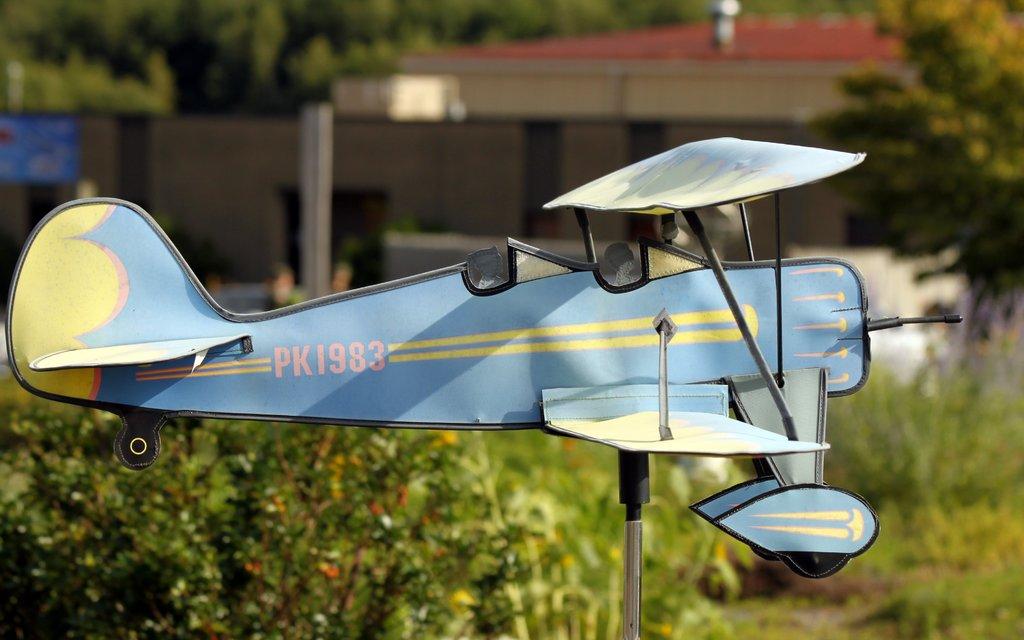What are the first two letters of this plane?
Provide a short and direct response. Pk. What number is the plane?
Give a very brief answer. Pk1983. 